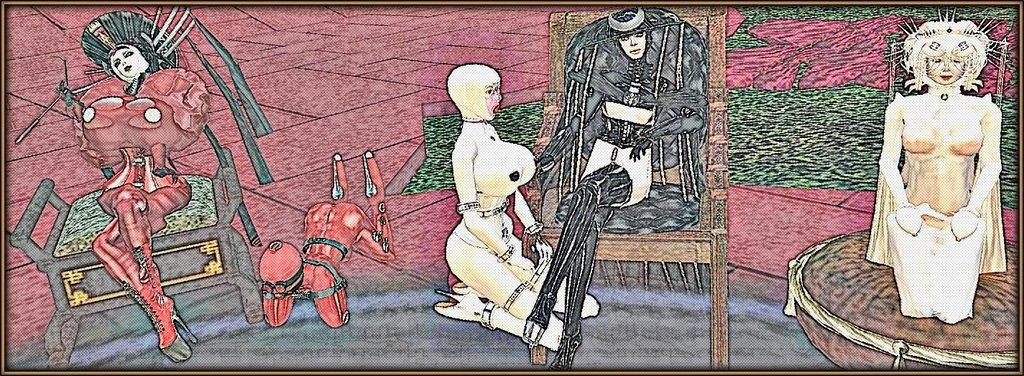What is the main subject of the image? The main subject of the image is a painting. What is happening in the painting? The painting depicts a few persons. What are the persons in the painting doing? Some of the persons in the painting are sitting on chairs. Can you tell me how many cakes are being served in the painting? There is no mention of cakes in the image or the painting; it only depicts a few persons and some of them sitting on chairs. 